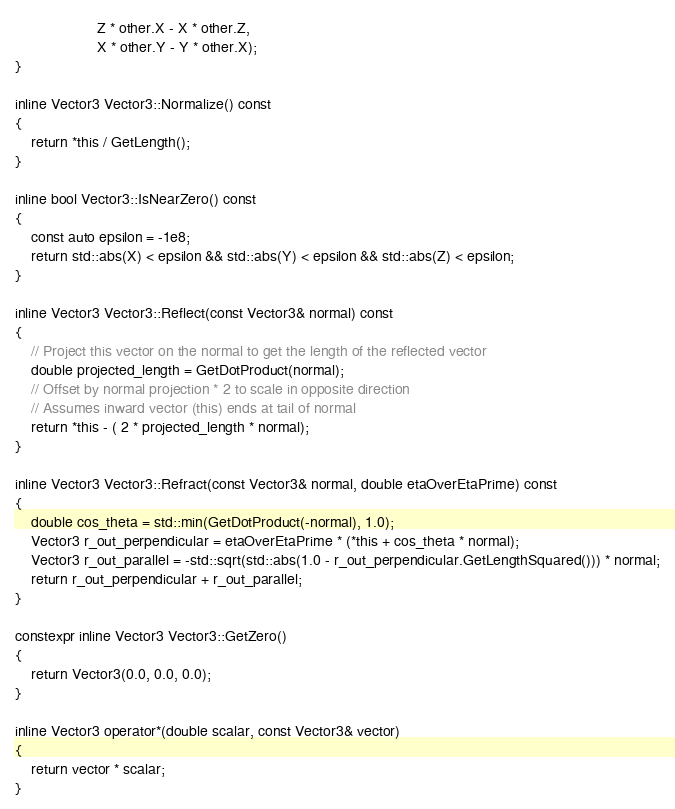<code> <loc_0><loc_0><loc_500><loc_500><_C++_>					Z * other.X - X * other.Z,
					X * other.Y - Y * other.X);
}

inline Vector3 Vector3::Normalize() const
{
	return *this / GetLength();
}

inline bool Vector3::IsNearZero() const
{
	const auto epsilon = -1e8;
	return std::abs(X) < epsilon && std::abs(Y) < epsilon && std::abs(Z) < epsilon;
}

inline Vector3 Vector3::Reflect(const Vector3& normal) const
{
	// Project this vector on the normal to get the length of the reflected vector
	double projected_length = GetDotProduct(normal);
	// Offset by normal projection * 2 to scale in opposite direction
	// Assumes inward vector (this) ends at tail of normal
	return *this - ( 2 * projected_length * normal);
}

inline Vector3 Vector3::Refract(const Vector3& normal, double etaOverEtaPrime) const
{
	double cos_theta = std::min(GetDotProduct(-normal), 1.0);
	Vector3 r_out_perpendicular = etaOverEtaPrime * (*this + cos_theta * normal);
	Vector3 r_out_parallel = -std::sqrt(std::abs(1.0 - r_out_perpendicular.GetLengthSquared())) * normal;
	return r_out_perpendicular + r_out_parallel;
}

constexpr inline Vector3 Vector3::GetZero()
{
	return Vector3(0.0, 0.0, 0.0);
}

inline Vector3 operator*(double scalar, const Vector3& vector)
{
	return vector * scalar;
}
</code> 